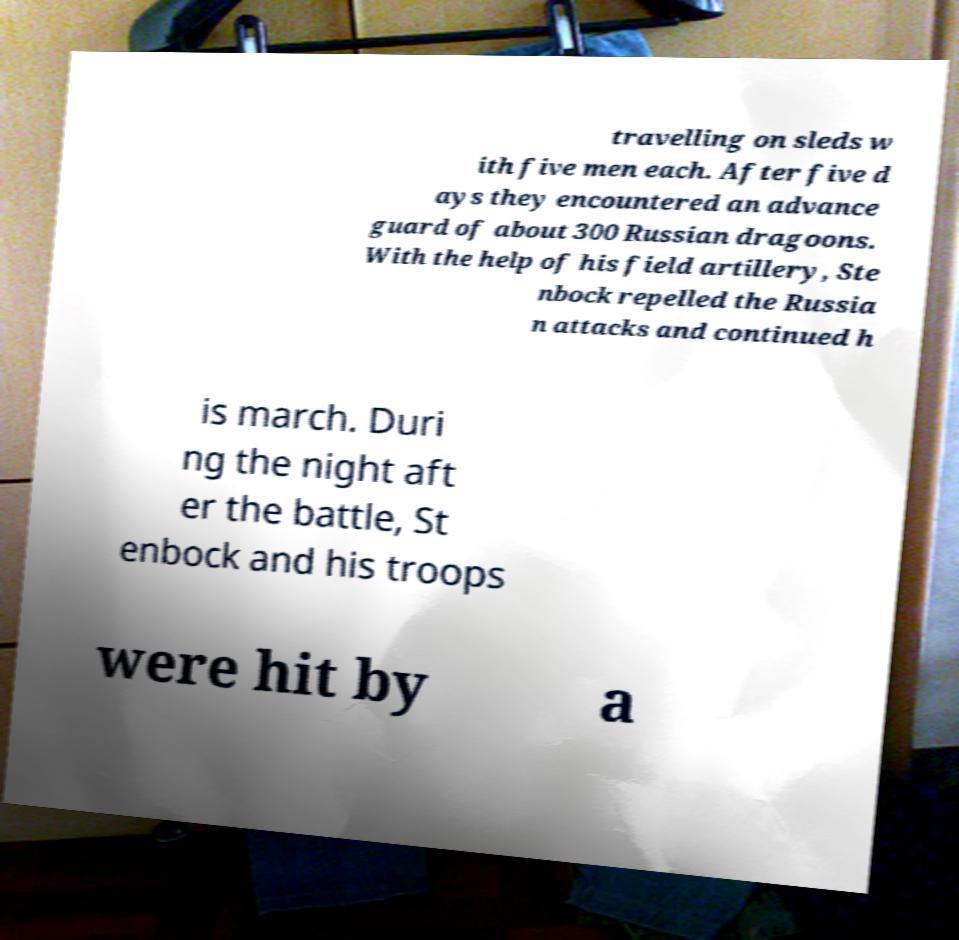I need the written content from this picture converted into text. Can you do that? travelling on sleds w ith five men each. After five d ays they encountered an advance guard of about 300 Russian dragoons. With the help of his field artillery, Ste nbock repelled the Russia n attacks and continued h is march. Duri ng the night aft er the battle, St enbock and his troops were hit by a 